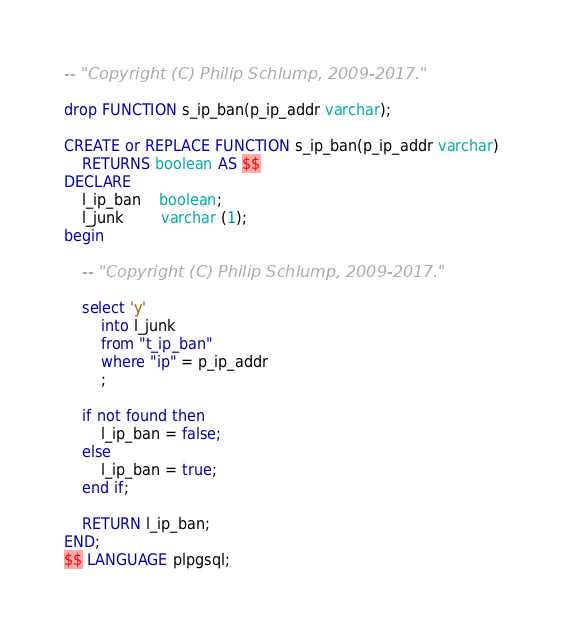<code> <loc_0><loc_0><loc_500><loc_500><_SQL_>





-- "Copyright (C) Philip Schlump, 2009-2017." 

drop FUNCTION s_ip_ban(p_ip_addr varchar);

CREATE or REPLACE FUNCTION s_ip_ban(p_ip_addr varchar)
	RETURNS boolean AS $$
DECLARE
	l_ip_ban 	boolean;
	l_junk		varchar (1);
begin

	-- "Copyright (C) Philip Schlump, 2009-2017." 

	select 'y' 
		into l_junk
		from "t_ip_ban"
		where "ip" = p_ip_addr
		;

	if not found then
		l_ip_ban = false;
	else
		l_ip_ban = true;
	end if;

	RETURN l_ip_ban;
END;
$$ LANGUAGE plpgsql;

</code> 